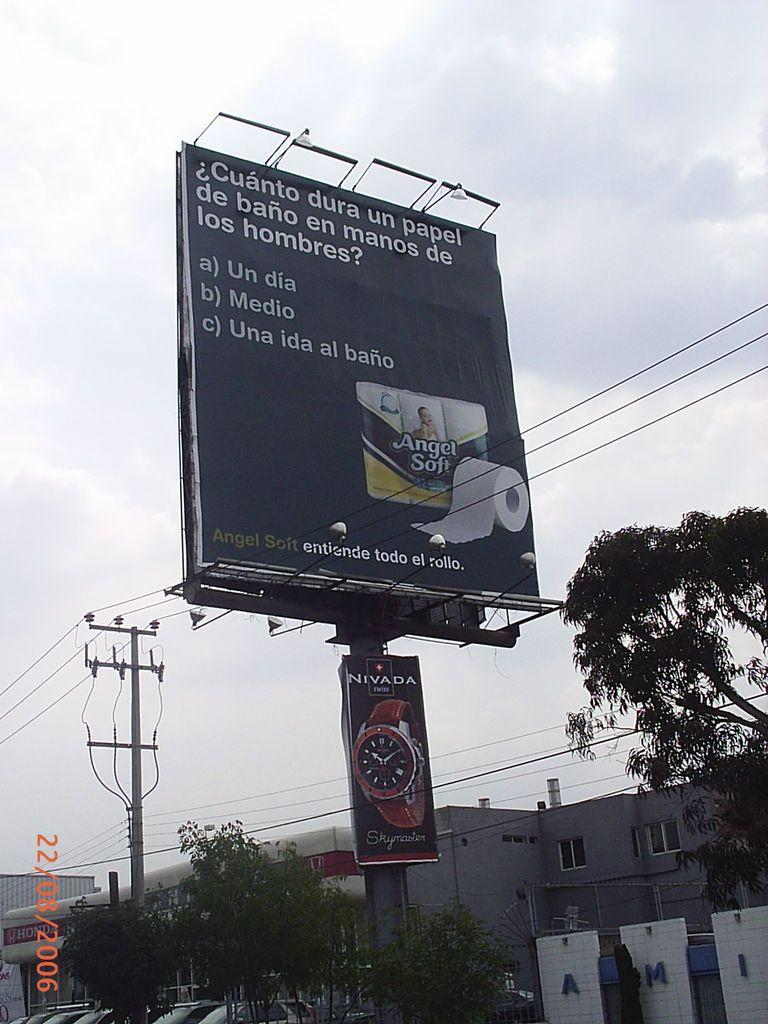<image>
Relay a brief, clear account of the picture shown. An advertisement in spanish about toilet paper hangs above a street. 